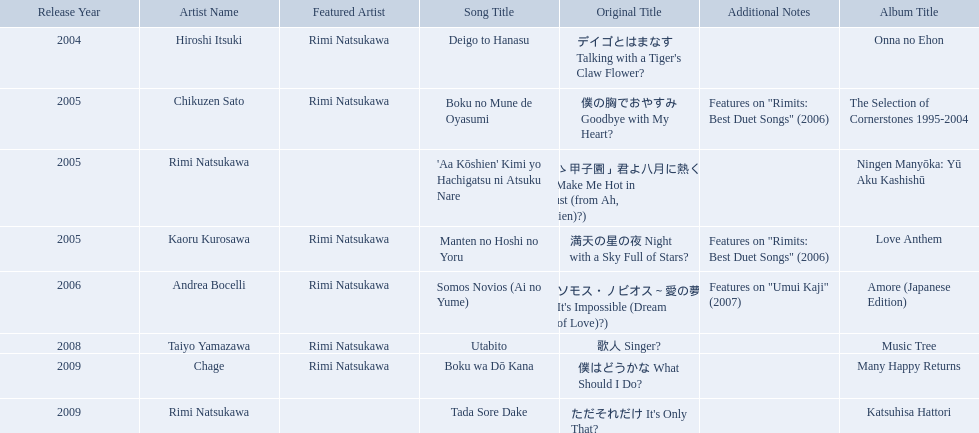What year was onna no ehon released? 2004. What year was music tree released? 2008. Which of the two was not released in 2004? Music Tree. What are all of the titles? Deigo to Hanasu (デイゴとはまなす Talking with a Tiger's Claw Flower?), Boku no Mune de Oyasumi (僕の胸でおやすみ Goodbye with My Heart?), 'Aa Kōshien' Kimi yo Hachigatsu ni Atsuku Nare (「あゝ甲子園」君よ八月に熱くなれ You Make Me Hot in August (from Ah, Kōshien)?), Manten no Hoshi no Yoru (満天の星の夜 Night with a Sky Full of Stars?), Somos Novios (Ai no Yume) (ソモス・ノビオス～愛の夢 It's Impossible (Dream of Love)?), Utabito (歌人 Singer?), Boku wa Dō Kana (僕はどうかな What Should I Do?), Tada Sore Dake (ただそれだけ It's Only That?). What are their notes? , Features on "Rimits: Best Duet Songs" (2006), , Features on "Rimits: Best Duet Songs" (2006), Features on "Umui Kaji" (2007), , , . Which title shares its notes with manten no hoshi no yoru (man tian noxing noye night with a sky full of stars?)? Boku no Mune de Oyasumi (僕の胸でおやすみ Goodbye with My Heart?). What are the notes for sky full of stars? Features on "Rimits: Best Duet Songs" (2006). What other song features this same note? Boku no Mune de Oyasumi (僕の胸でおやすみ Goodbye with My Heart?). Which title of the rimi natsukawa discography was released in the 2004? Deigo to Hanasu (デイゴとはまなす Talking with a Tiger's Claw Flower?). Which title has notes that features on/rimits. best duet songs\2006 Manten no Hoshi no Yoru (満天の星の夜 Night with a Sky Full of Stars?). Which title share the same notes as night with a sky full of stars? Boku no Mune de Oyasumi (僕の胸でおやすみ Goodbye with My Heart?). 